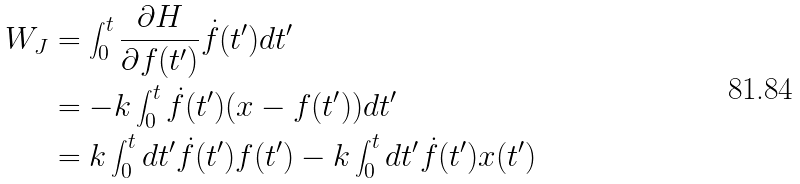Convert formula to latex. <formula><loc_0><loc_0><loc_500><loc_500>W _ { J } & = \int _ { 0 } ^ { t } \frac { \partial H } { \partial f ( t ^ { \prime } ) } \dot { f } ( t ^ { \prime } ) d t ^ { \prime } \\ & = - k \int _ { 0 } ^ { t } \dot { f } ( t ^ { \prime } ) ( x - f ( t ^ { \prime } ) ) d t ^ { \prime } \\ & = k \int _ { 0 } ^ { t } d t ^ { \prime } \dot { f } ( t ^ { \prime } ) f ( t ^ { \prime } ) - k \int _ { 0 } ^ { t } d t ^ { \prime } \dot { f } ( t ^ { \prime } ) x ( t ^ { \prime } )</formula> 